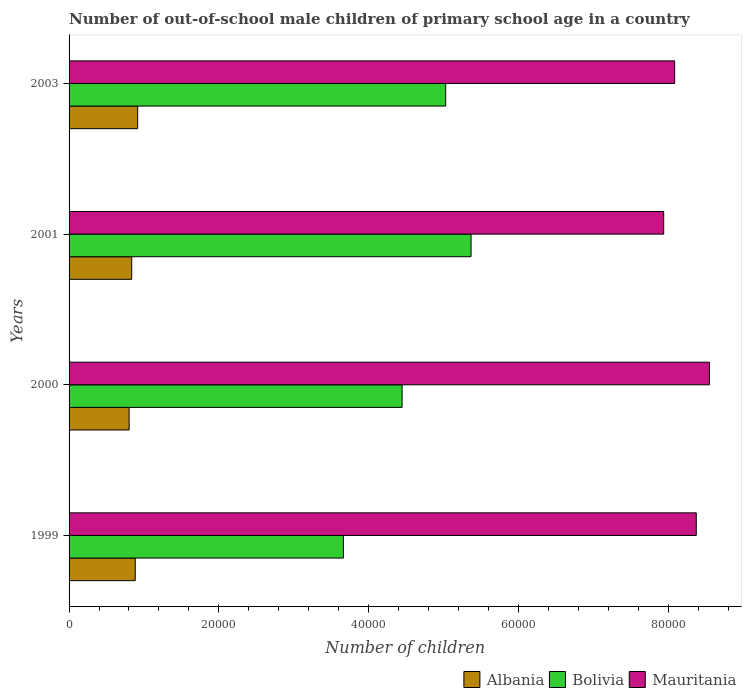How many different coloured bars are there?
Keep it short and to the point. 3. Are the number of bars per tick equal to the number of legend labels?
Provide a succinct answer. Yes. Are the number of bars on each tick of the Y-axis equal?
Your response must be concise. Yes. How many bars are there on the 3rd tick from the top?
Your answer should be compact. 3. What is the label of the 3rd group of bars from the top?
Ensure brevity in your answer.  2000. What is the number of out-of-school male children in Mauritania in 2003?
Your answer should be compact. 8.09e+04. Across all years, what is the maximum number of out-of-school male children in Albania?
Make the answer very short. 9158. Across all years, what is the minimum number of out-of-school male children in Albania?
Your answer should be very brief. 8021. In which year was the number of out-of-school male children in Albania minimum?
Give a very brief answer. 2000. What is the total number of out-of-school male children in Albania in the graph?
Offer a terse response. 3.44e+04. What is the difference between the number of out-of-school male children in Mauritania in 1999 and that in 2001?
Keep it short and to the point. 4353. What is the difference between the number of out-of-school male children in Albania in 2000 and the number of out-of-school male children in Mauritania in 1999?
Offer a terse response. -7.57e+04. What is the average number of out-of-school male children in Mauritania per year?
Keep it short and to the point. 8.24e+04. In the year 1999, what is the difference between the number of out-of-school male children in Bolivia and number of out-of-school male children in Albania?
Make the answer very short. 2.78e+04. In how many years, is the number of out-of-school male children in Mauritania greater than 24000 ?
Keep it short and to the point. 4. What is the ratio of the number of out-of-school male children in Albania in 2000 to that in 2003?
Your response must be concise. 0.88. Is the difference between the number of out-of-school male children in Bolivia in 2000 and 2003 greater than the difference between the number of out-of-school male children in Albania in 2000 and 2003?
Offer a terse response. No. What is the difference between the highest and the second highest number of out-of-school male children in Albania?
Your answer should be compact. 323. What is the difference between the highest and the lowest number of out-of-school male children in Bolivia?
Give a very brief answer. 1.70e+04. What does the 1st bar from the top in 2001 represents?
Your response must be concise. Mauritania. What does the 2nd bar from the bottom in 2003 represents?
Offer a terse response. Bolivia. How many bars are there?
Your answer should be compact. 12. Are all the bars in the graph horizontal?
Make the answer very short. Yes. What is the difference between two consecutive major ticks on the X-axis?
Provide a succinct answer. 2.00e+04. Does the graph contain grids?
Ensure brevity in your answer.  No. How many legend labels are there?
Your response must be concise. 3. What is the title of the graph?
Your answer should be compact. Number of out-of-school male children of primary school age in a country. Does "Tuvalu" appear as one of the legend labels in the graph?
Offer a terse response. No. What is the label or title of the X-axis?
Offer a very short reply. Number of children. What is the label or title of the Y-axis?
Keep it short and to the point. Years. What is the Number of children of Albania in 1999?
Provide a succinct answer. 8835. What is the Number of children in Bolivia in 1999?
Your response must be concise. 3.66e+04. What is the Number of children in Mauritania in 1999?
Keep it short and to the point. 8.38e+04. What is the Number of children of Albania in 2000?
Your answer should be very brief. 8021. What is the Number of children in Bolivia in 2000?
Provide a succinct answer. 4.45e+04. What is the Number of children of Mauritania in 2000?
Offer a terse response. 8.55e+04. What is the Number of children in Albania in 2001?
Make the answer very short. 8367. What is the Number of children of Bolivia in 2001?
Give a very brief answer. 5.37e+04. What is the Number of children of Mauritania in 2001?
Keep it short and to the point. 7.94e+04. What is the Number of children in Albania in 2003?
Provide a short and direct response. 9158. What is the Number of children in Bolivia in 2003?
Your answer should be compact. 5.03e+04. What is the Number of children in Mauritania in 2003?
Ensure brevity in your answer.  8.09e+04. Across all years, what is the maximum Number of children in Albania?
Provide a succinct answer. 9158. Across all years, what is the maximum Number of children of Bolivia?
Provide a succinct answer. 5.37e+04. Across all years, what is the maximum Number of children of Mauritania?
Keep it short and to the point. 8.55e+04. Across all years, what is the minimum Number of children in Albania?
Keep it short and to the point. 8021. Across all years, what is the minimum Number of children in Bolivia?
Keep it short and to the point. 3.66e+04. Across all years, what is the minimum Number of children in Mauritania?
Provide a succinct answer. 7.94e+04. What is the total Number of children in Albania in the graph?
Keep it short and to the point. 3.44e+04. What is the total Number of children of Bolivia in the graph?
Make the answer very short. 1.85e+05. What is the total Number of children in Mauritania in the graph?
Offer a terse response. 3.30e+05. What is the difference between the Number of children in Albania in 1999 and that in 2000?
Provide a short and direct response. 814. What is the difference between the Number of children of Bolivia in 1999 and that in 2000?
Your answer should be very brief. -7837. What is the difference between the Number of children in Mauritania in 1999 and that in 2000?
Keep it short and to the point. -1762. What is the difference between the Number of children of Albania in 1999 and that in 2001?
Your answer should be compact. 468. What is the difference between the Number of children in Bolivia in 1999 and that in 2001?
Make the answer very short. -1.70e+04. What is the difference between the Number of children of Mauritania in 1999 and that in 2001?
Your answer should be compact. 4353. What is the difference between the Number of children in Albania in 1999 and that in 2003?
Provide a succinct answer. -323. What is the difference between the Number of children in Bolivia in 1999 and that in 2003?
Keep it short and to the point. -1.37e+04. What is the difference between the Number of children in Mauritania in 1999 and that in 2003?
Give a very brief answer. 2889. What is the difference between the Number of children in Albania in 2000 and that in 2001?
Ensure brevity in your answer.  -346. What is the difference between the Number of children of Bolivia in 2000 and that in 2001?
Offer a very short reply. -9210. What is the difference between the Number of children of Mauritania in 2000 and that in 2001?
Give a very brief answer. 6115. What is the difference between the Number of children of Albania in 2000 and that in 2003?
Provide a short and direct response. -1137. What is the difference between the Number of children of Bolivia in 2000 and that in 2003?
Keep it short and to the point. -5820. What is the difference between the Number of children in Mauritania in 2000 and that in 2003?
Provide a succinct answer. 4651. What is the difference between the Number of children of Albania in 2001 and that in 2003?
Give a very brief answer. -791. What is the difference between the Number of children in Bolivia in 2001 and that in 2003?
Provide a succinct answer. 3390. What is the difference between the Number of children in Mauritania in 2001 and that in 2003?
Offer a terse response. -1464. What is the difference between the Number of children in Albania in 1999 and the Number of children in Bolivia in 2000?
Provide a succinct answer. -3.56e+04. What is the difference between the Number of children in Albania in 1999 and the Number of children in Mauritania in 2000?
Your answer should be compact. -7.67e+04. What is the difference between the Number of children of Bolivia in 1999 and the Number of children of Mauritania in 2000?
Offer a very short reply. -4.89e+04. What is the difference between the Number of children of Albania in 1999 and the Number of children of Bolivia in 2001?
Offer a terse response. -4.48e+04. What is the difference between the Number of children of Albania in 1999 and the Number of children of Mauritania in 2001?
Make the answer very short. -7.06e+04. What is the difference between the Number of children of Bolivia in 1999 and the Number of children of Mauritania in 2001?
Provide a short and direct response. -4.28e+04. What is the difference between the Number of children of Albania in 1999 and the Number of children of Bolivia in 2003?
Your answer should be very brief. -4.15e+04. What is the difference between the Number of children in Albania in 1999 and the Number of children in Mauritania in 2003?
Make the answer very short. -7.20e+04. What is the difference between the Number of children of Bolivia in 1999 and the Number of children of Mauritania in 2003?
Keep it short and to the point. -4.42e+04. What is the difference between the Number of children in Albania in 2000 and the Number of children in Bolivia in 2001?
Provide a short and direct response. -4.57e+04. What is the difference between the Number of children in Albania in 2000 and the Number of children in Mauritania in 2001?
Provide a succinct answer. -7.14e+04. What is the difference between the Number of children in Bolivia in 2000 and the Number of children in Mauritania in 2001?
Keep it short and to the point. -3.49e+04. What is the difference between the Number of children of Albania in 2000 and the Number of children of Bolivia in 2003?
Offer a very short reply. -4.23e+04. What is the difference between the Number of children in Albania in 2000 and the Number of children in Mauritania in 2003?
Your response must be concise. -7.28e+04. What is the difference between the Number of children of Bolivia in 2000 and the Number of children of Mauritania in 2003?
Make the answer very short. -3.64e+04. What is the difference between the Number of children of Albania in 2001 and the Number of children of Bolivia in 2003?
Keep it short and to the point. -4.19e+04. What is the difference between the Number of children of Albania in 2001 and the Number of children of Mauritania in 2003?
Your answer should be very brief. -7.25e+04. What is the difference between the Number of children of Bolivia in 2001 and the Number of children of Mauritania in 2003?
Keep it short and to the point. -2.72e+04. What is the average Number of children in Albania per year?
Ensure brevity in your answer.  8595.25. What is the average Number of children in Bolivia per year?
Offer a terse response. 4.63e+04. What is the average Number of children in Mauritania per year?
Make the answer very short. 8.24e+04. In the year 1999, what is the difference between the Number of children in Albania and Number of children in Bolivia?
Your answer should be very brief. -2.78e+04. In the year 1999, what is the difference between the Number of children of Albania and Number of children of Mauritania?
Provide a short and direct response. -7.49e+04. In the year 1999, what is the difference between the Number of children of Bolivia and Number of children of Mauritania?
Your response must be concise. -4.71e+04. In the year 2000, what is the difference between the Number of children in Albania and Number of children in Bolivia?
Give a very brief answer. -3.65e+04. In the year 2000, what is the difference between the Number of children of Albania and Number of children of Mauritania?
Provide a succinct answer. -7.75e+04. In the year 2000, what is the difference between the Number of children of Bolivia and Number of children of Mauritania?
Your response must be concise. -4.10e+04. In the year 2001, what is the difference between the Number of children of Albania and Number of children of Bolivia?
Provide a short and direct response. -4.53e+04. In the year 2001, what is the difference between the Number of children in Albania and Number of children in Mauritania?
Offer a terse response. -7.10e+04. In the year 2001, what is the difference between the Number of children in Bolivia and Number of children in Mauritania?
Your response must be concise. -2.57e+04. In the year 2003, what is the difference between the Number of children in Albania and Number of children in Bolivia?
Make the answer very short. -4.11e+04. In the year 2003, what is the difference between the Number of children in Albania and Number of children in Mauritania?
Offer a very short reply. -7.17e+04. In the year 2003, what is the difference between the Number of children of Bolivia and Number of children of Mauritania?
Ensure brevity in your answer.  -3.06e+04. What is the ratio of the Number of children in Albania in 1999 to that in 2000?
Provide a short and direct response. 1.1. What is the ratio of the Number of children in Bolivia in 1999 to that in 2000?
Your answer should be compact. 0.82. What is the ratio of the Number of children in Mauritania in 1999 to that in 2000?
Ensure brevity in your answer.  0.98. What is the ratio of the Number of children of Albania in 1999 to that in 2001?
Provide a succinct answer. 1.06. What is the ratio of the Number of children of Bolivia in 1999 to that in 2001?
Your answer should be compact. 0.68. What is the ratio of the Number of children in Mauritania in 1999 to that in 2001?
Provide a short and direct response. 1.05. What is the ratio of the Number of children of Albania in 1999 to that in 2003?
Your answer should be very brief. 0.96. What is the ratio of the Number of children of Bolivia in 1999 to that in 2003?
Keep it short and to the point. 0.73. What is the ratio of the Number of children in Mauritania in 1999 to that in 2003?
Your response must be concise. 1.04. What is the ratio of the Number of children of Albania in 2000 to that in 2001?
Offer a terse response. 0.96. What is the ratio of the Number of children in Bolivia in 2000 to that in 2001?
Provide a short and direct response. 0.83. What is the ratio of the Number of children in Mauritania in 2000 to that in 2001?
Offer a very short reply. 1.08. What is the ratio of the Number of children in Albania in 2000 to that in 2003?
Your answer should be very brief. 0.88. What is the ratio of the Number of children in Bolivia in 2000 to that in 2003?
Give a very brief answer. 0.88. What is the ratio of the Number of children in Mauritania in 2000 to that in 2003?
Offer a very short reply. 1.06. What is the ratio of the Number of children in Albania in 2001 to that in 2003?
Make the answer very short. 0.91. What is the ratio of the Number of children in Bolivia in 2001 to that in 2003?
Provide a short and direct response. 1.07. What is the ratio of the Number of children of Mauritania in 2001 to that in 2003?
Provide a succinct answer. 0.98. What is the difference between the highest and the second highest Number of children in Albania?
Your answer should be very brief. 323. What is the difference between the highest and the second highest Number of children of Bolivia?
Your response must be concise. 3390. What is the difference between the highest and the second highest Number of children of Mauritania?
Provide a succinct answer. 1762. What is the difference between the highest and the lowest Number of children of Albania?
Your answer should be very brief. 1137. What is the difference between the highest and the lowest Number of children in Bolivia?
Ensure brevity in your answer.  1.70e+04. What is the difference between the highest and the lowest Number of children in Mauritania?
Provide a short and direct response. 6115. 